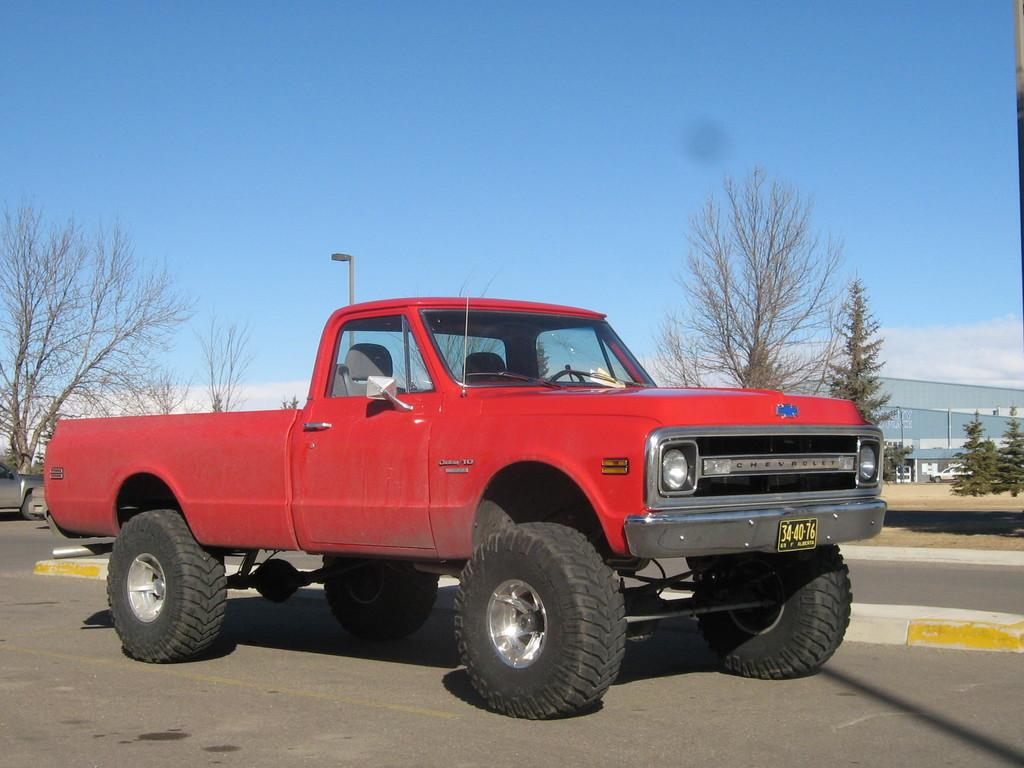What types of vehicles are in the image? The image contains vehicles, but the specific types cannot be determined from the provided facts. What structure is present in the image? There is a building in the image. What is the purpose of the streetlight in the image? The streetlight in the image is likely for illumination purposes. What type of vegetation is visible in the image? There are trees in the image. What part of the natural environment is visible in the image? The sky is visible in the image. What type of beetle can be seen wearing a shirt in the image? There is no beetle wearing a shirt present in the image. What idea is being expressed by the vehicles in the image? The image does not convey any specific ideas or concepts; it simply depicts vehicles, a building, a streetlight, trees, and the sky. 